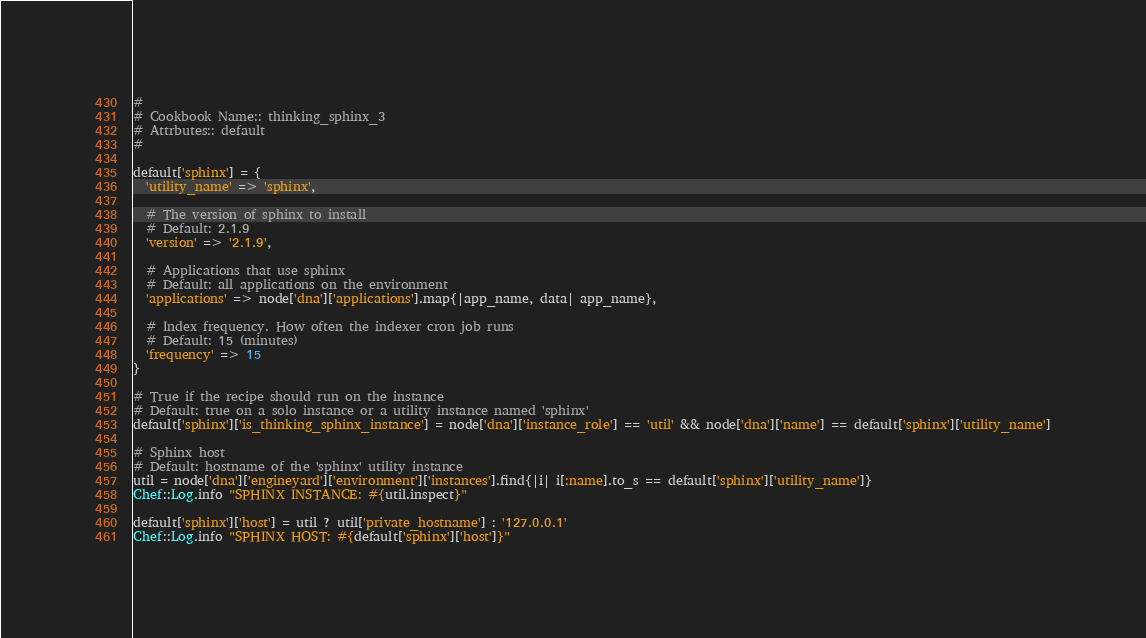Convert code to text. <code><loc_0><loc_0><loc_500><loc_500><_Ruby_>#
# Cookbook Name:: thinking_sphinx_3
# Attrbutes:: default
#

default['sphinx'] = {
  'utility_name' => 'sphinx',

  # The version of sphinx to install
  # Default: 2.1.9
  'version' => '2.1.9',
  
  # Applications that use sphinx
  # Default: all applications on the environment
  'applications' => node['dna']['applications'].map{|app_name, data| app_name},
  
  # Index frequency. How often the indexer cron job runs
  # Default: 15 (minutes)
  'frequency' => 15
}

# True if the recipe should run on the instance
# Default: true on a solo instance or a utility instance named 'sphinx'
default['sphinx']['is_thinking_sphinx_instance'] = node['dna']['instance_role'] == 'util' && node['dna']['name'] == default['sphinx']['utility_name']

# Sphinx host
# Default: hostname of the 'sphinx' utility instance
util = node['dna']['engineyard']['environment']['instances'].find{|i| i[:name].to_s == default['sphinx']['utility_name']}
Chef::Log.info "SPHINX INSTANCE: #{util.inspect}"

default['sphinx']['host'] = util ? util['private_hostname'] : '127.0.0.1'
Chef::Log.info "SPHINX HOST: #{default['sphinx']['host']}"

</code> 